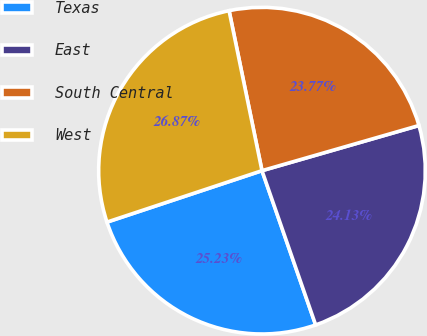Convert chart. <chart><loc_0><loc_0><loc_500><loc_500><pie_chart><fcel>Texas<fcel>East<fcel>South Central<fcel>West<nl><fcel>25.23%<fcel>24.13%<fcel>23.77%<fcel>26.87%<nl></chart> 